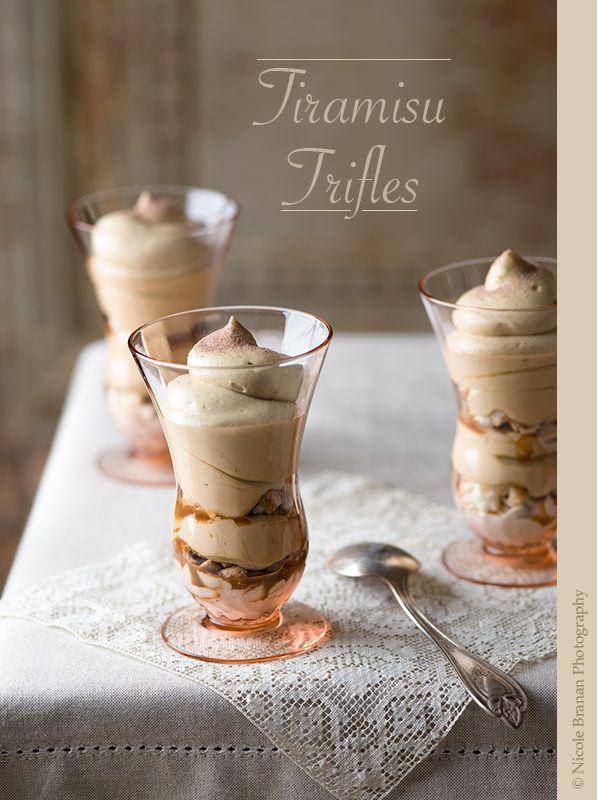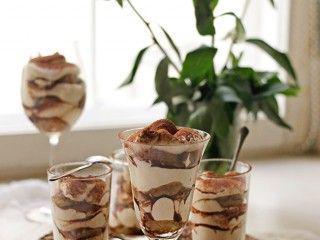The first image is the image on the left, the second image is the image on the right. Given the left and right images, does the statement "A bottle of irish cream sits near the desserts in one of the images." hold true? Answer yes or no. No. The first image is the image on the left, the second image is the image on the right. Considering the images on both sides, is "A bottle of liqueur is visible behind a creamy dessert with brown chunks in it." valid? Answer yes or no. No. 